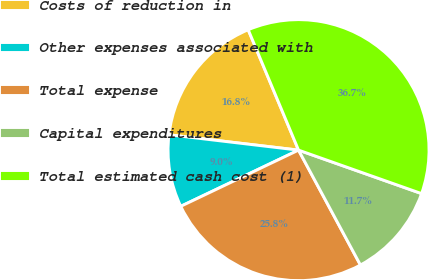Convert chart. <chart><loc_0><loc_0><loc_500><loc_500><pie_chart><fcel>Costs of reduction in<fcel>Other expenses associated with<fcel>Total expense<fcel>Capital expenditures<fcel>Total estimated cash cost (1)<nl><fcel>16.82%<fcel>8.96%<fcel>25.78%<fcel>11.73%<fcel>36.71%<nl></chart> 